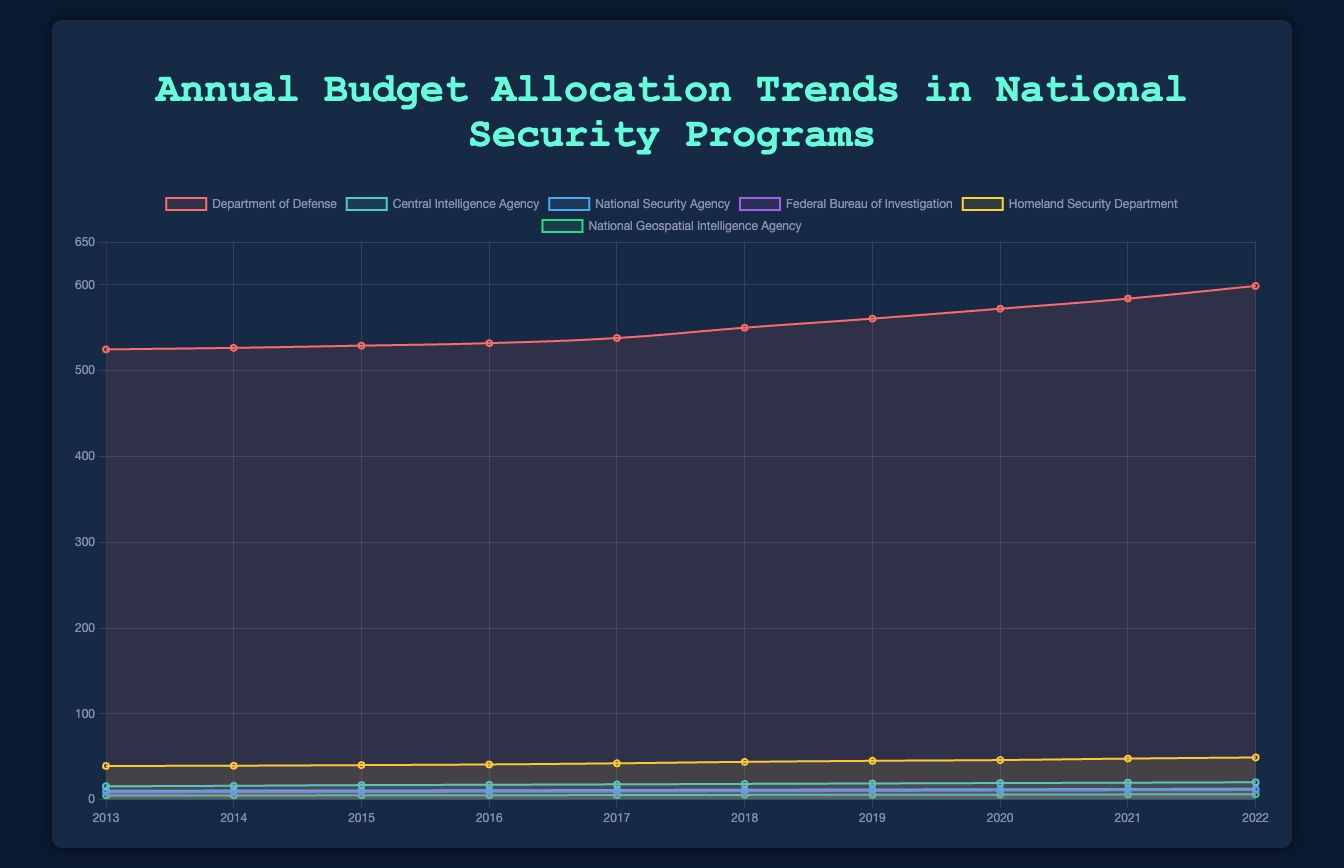Which department had the highest budget allocation in 2022? By looking at the plotted data for 2022, the Department of Defense has the highest budget allocation among all departments.
Answer: Department of Defense How much did the budget for the Central Intelligence Agency increase from 2013 to 2022? In 2013, the budget for the Central Intelligence Agency was 15.5, while in 2022, it was 20.2. The increase is calculated as 20.2 - 15.5 = 4.7.
Answer: 4.7 Between the National Security Agency and the Federal Bureau of Investigation, which one had a higher budget in 2017? According to the data for 2017, the budget for the National Security Agency was 11.2, and for the Federal Bureau of Investigation, it was 9.3. Thus, the National Security Agency had a higher budget.
Answer: National Security Agency What is the average budget allocation for the Homeland Security Department over the period 2013-2022? The budget allocations for the Homeland Security Department from 2013 to 2022 are summed and then divided by the number of years: (39.2 + 39.5 + 40.2 + 41.0 + 42.3 + 44.0 + 45.2 + 46.1 + 47.8 + 49.1) = 434.4. The average is 434.4 / 10 = 43.44.
Answer: 43.44 Which department had the lowest budget allocation in 2015? By reviewing the plotted data for 2015, the National Geospatial Intelligence Agency had the lowest budget allocation at 5.0.
Answer: National Geospatial Intelligence Agency Did the Department of Defense’s budget increase or decrease between 2016 and 2020? From the plotted data, the budget for the Department of Defense in 2016 was 532.1, and in 2020, it was 572.2. Since 572.2 is greater than 532.1, the budget increased.
Answer: Increase What was the total budget allocation for all departments combined in 2019? The total budget allocation for 2019 is the sum of the budgets for all departments: 560.7 (Department of Defense) + 18.8 (Central Intelligence Agency) + 11.8 (National Security Agency) + 10.0 (Federal Bureau of Investigation) + 45.2 (Homeland Security Department) + 5.6 (National Geospatial Intelligence Agency) = 652.1.
Answer: 652.1 Which year experienced the highest increase in the Central Intelligence Agency’s budget from the previous year? By examining the year-over-year increments for the Central Intelligence Agency, the most significant increase occurred between 2018 (18.3) and 2019 (18.8), an increase of 0.5.
Answer: 2019 By how much did the budget for the National Geospatial Intelligence Agency change from 2014 to 2016? From 2014 to 2016, the budget for the National Geospatial Intelligence Agency changed from 4.8 to 5.1. The change is 5.1 - 4.8 = 0.3.
Answer: 0.3 Which department had a budget allocation greater than the Central Intelligence Agency but less than the Department of Defense in 2021? In 2021, the budget allocations show that the Department of Homeland Security had a budget of 47.8, which is more than the Central Intelligence Agency’s 19.7 but less than the Department of Defense’s 584.0.
Answer: Homeland Security Department 